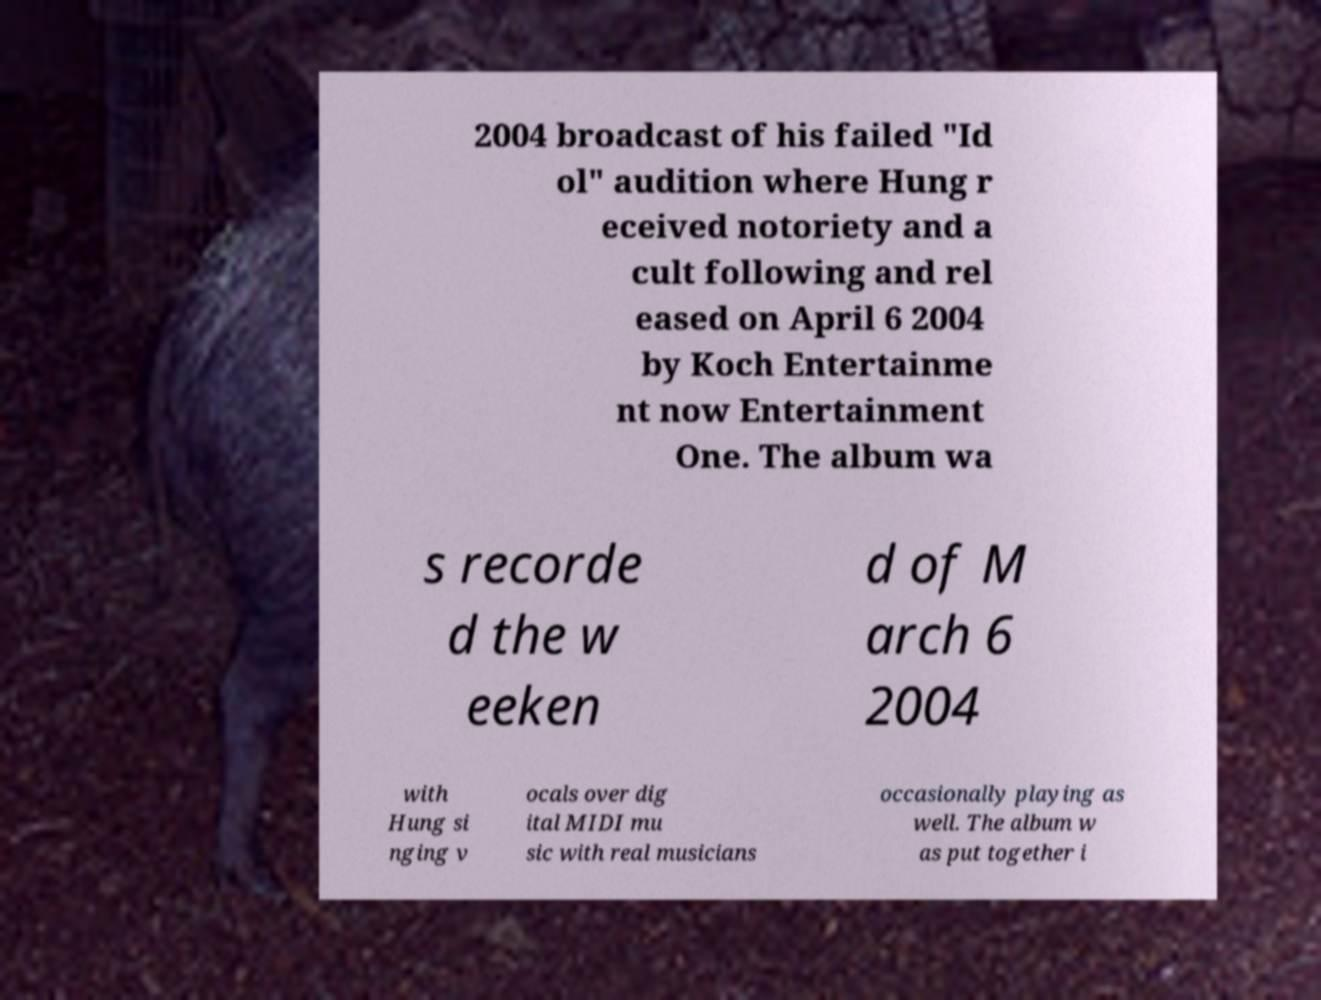What messages or text are displayed in this image? I need them in a readable, typed format. 2004 broadcast of his failed "Id ol" audition where Hung r eceived notoriety and a cult following and rel eased on April 6 2004 by Koch Entertainme nt now Entertainment One. The album wa s recorde d the w eeken d of M arch 6 2004 with Hung si nging v ocals over dig ital MIDI mu sic with real musicians occasionally playing as well. The album w as put together i 